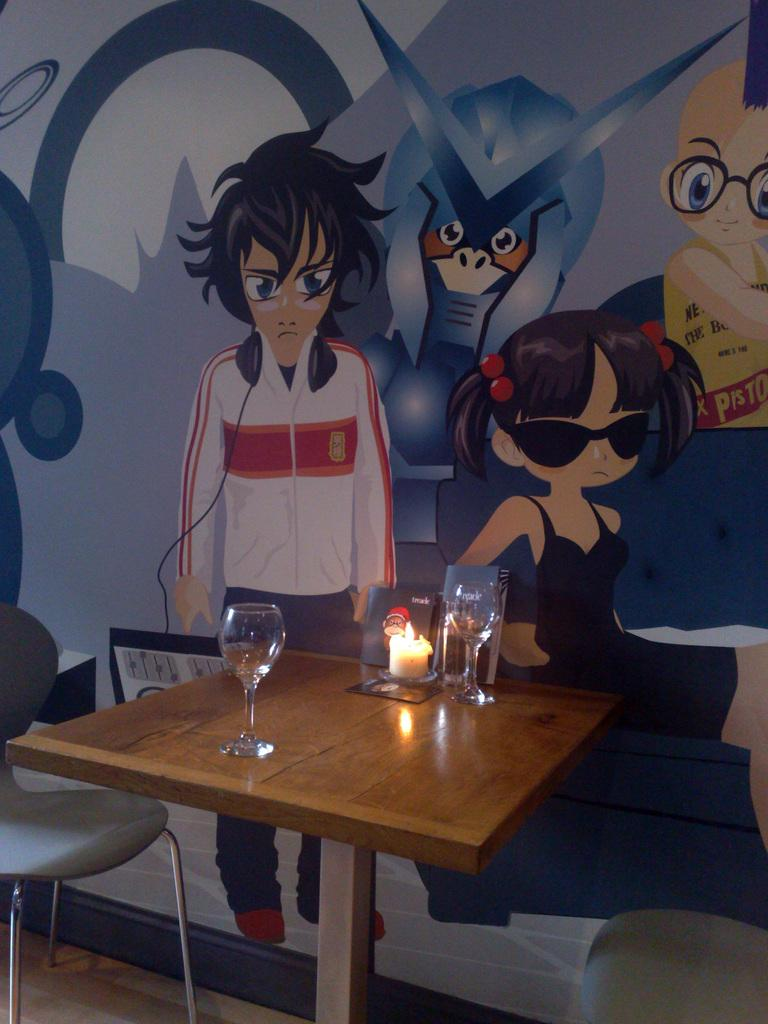What type of furniture is present in the image? There are chairs in the image. What can be seen on the table in the image? There are glasses and a candle on the table in the image. What is the appearance of the wall in the image? The wall has a multi-colored appearance and has cartoon toys painted on it. What objects might be used for drinking in the image? There are glasses in the image that might be used for drinking. How many birds are sitting on the table in the image? There are no birds present in the image. What type of shade is covering the table in the image? There is no shade covering the table in the image. 